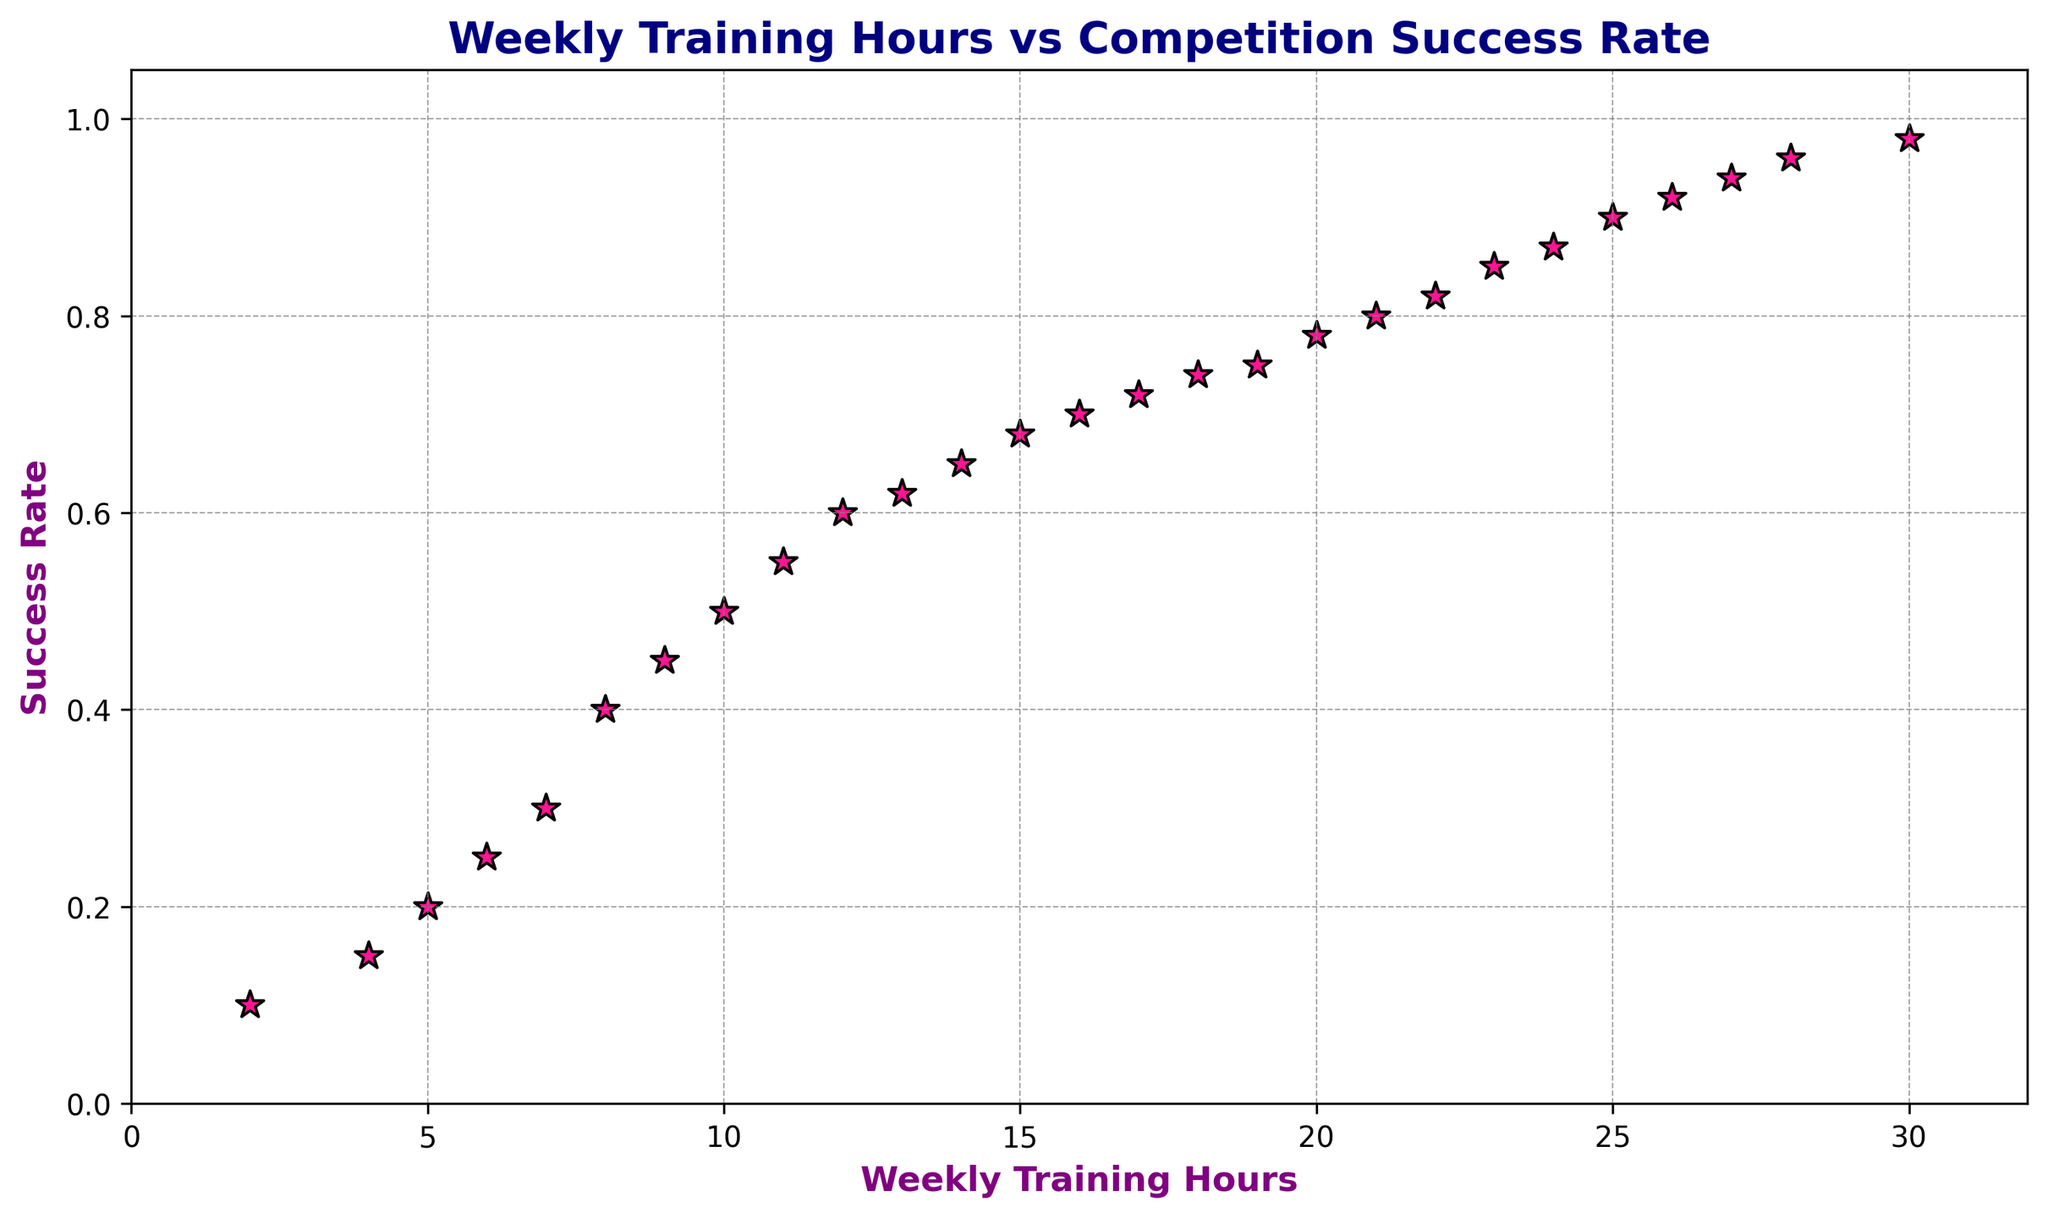what is the success rate at 10 weekly training hours? Looking at the scatter plot, find the data point with 10 weekly training hours and note its corresponding success rate.
Answer: 0.5 how many training hours is required to achieve a success rate of 0.9? Locate the point on the y-axis that is 0.9 and trace it horizontally to find the corresponding weekly training hours on the x-axis.
Answer: 25 is the success rate generally increasing with the weekly training hours? Observe the trend in the scatter plot by following the data points from left to right, noting whether the success rate (y-axis) increases as the weekly training hours (x-axis) increase.
Answer: Yes does the scatter plot follow a linear or non-linear trend? Analyze the overall distribution and pattern of the data points to determine if they form a mostly straight line (linear) or curve (non-linear).
Answer: Non-linear which training hour range has the steepest increase in success rate? Identify the section of the scatter plot where the success rate (y-axis) increases most rapidly with a small increase in weekly training hours (x-axis).
Answer: 6 to 10 is there any success rate greater than 0.8 with less than 20 weekly training hours? Compare the success rates (y-axis) of data points that fall to the left of the 20 weekly training hours (x-axis) to see if any exceed 0.8.
Answer: No what is the maximum success rate observed in the plot? Identify the highest point on the y-axis among all data points in the scatter plot.
Answer: 0.98 what happens to the success rate when training hours exceed 26 hours per week? Observe the data points beyond the 26-weekly training hours mark on the x-axis to see the corresponding success rates.
Answer: Success rate reaches 0.98 and does not significantly increase how does the visual marker help identify key points in the scatter plot? Describe how the color, size, and shape of the markers (deeppink, size 100, star shape with black edge) make individual points stand out and easy to read.
Answer: Distinctive color and shape improve visibility and differentiation of data points what's the change in success rate between 8 and 12 weekly training hours? Subtract the success rate at 8 weekly training hours from the success rate at 12 weekly training hours to determine the change.
Answer: 0.2 